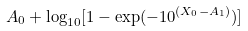<formula> <loc_0><loc_0><loc_500><loc_500>A _ { 0 } + \log _ { 1 0 } [ 1 - \exp ( - 1 0 ^ { ( X _ { 0 } - A _ { 1 } ) } ) ]</formula> 